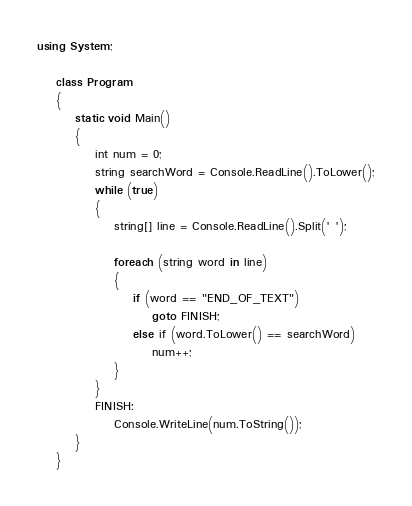Convert code to text. <code><loc_0><loc_0><loc_500><loc_500><_C#_>using System;

    class Program
    {
        static void Main()
        {
            int num = 0;
            string searchWord = Console.ReadLine().ToLower();
            while (true)
            {
                string[] line = Console.ReadLine().Split(' ');

                foreach (string word in line)
                {
                    if (word == "END_OF_TEXT")
                        goto FINISH;
                    else if (word.ToLower() == searchWord)
                        num++;
                }
            }
            FINISH:
                Console.WriteLine(num.ToString());
        }
    }</code> 